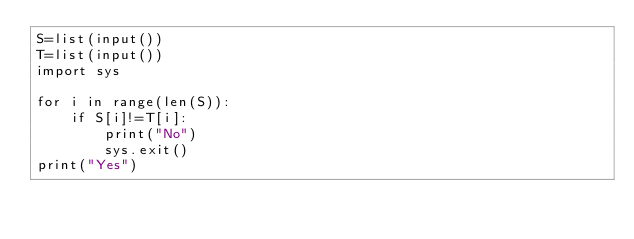Convert code to text. <code><loc_0><loc_0><loc_500><loc_500><_Python_>S=list(input())
T=list(input())
import sys

for i in range(len(S)):
    if S[i]!=T[i]:
        print("No")
        sys.exit()
print("Yes")</code> 